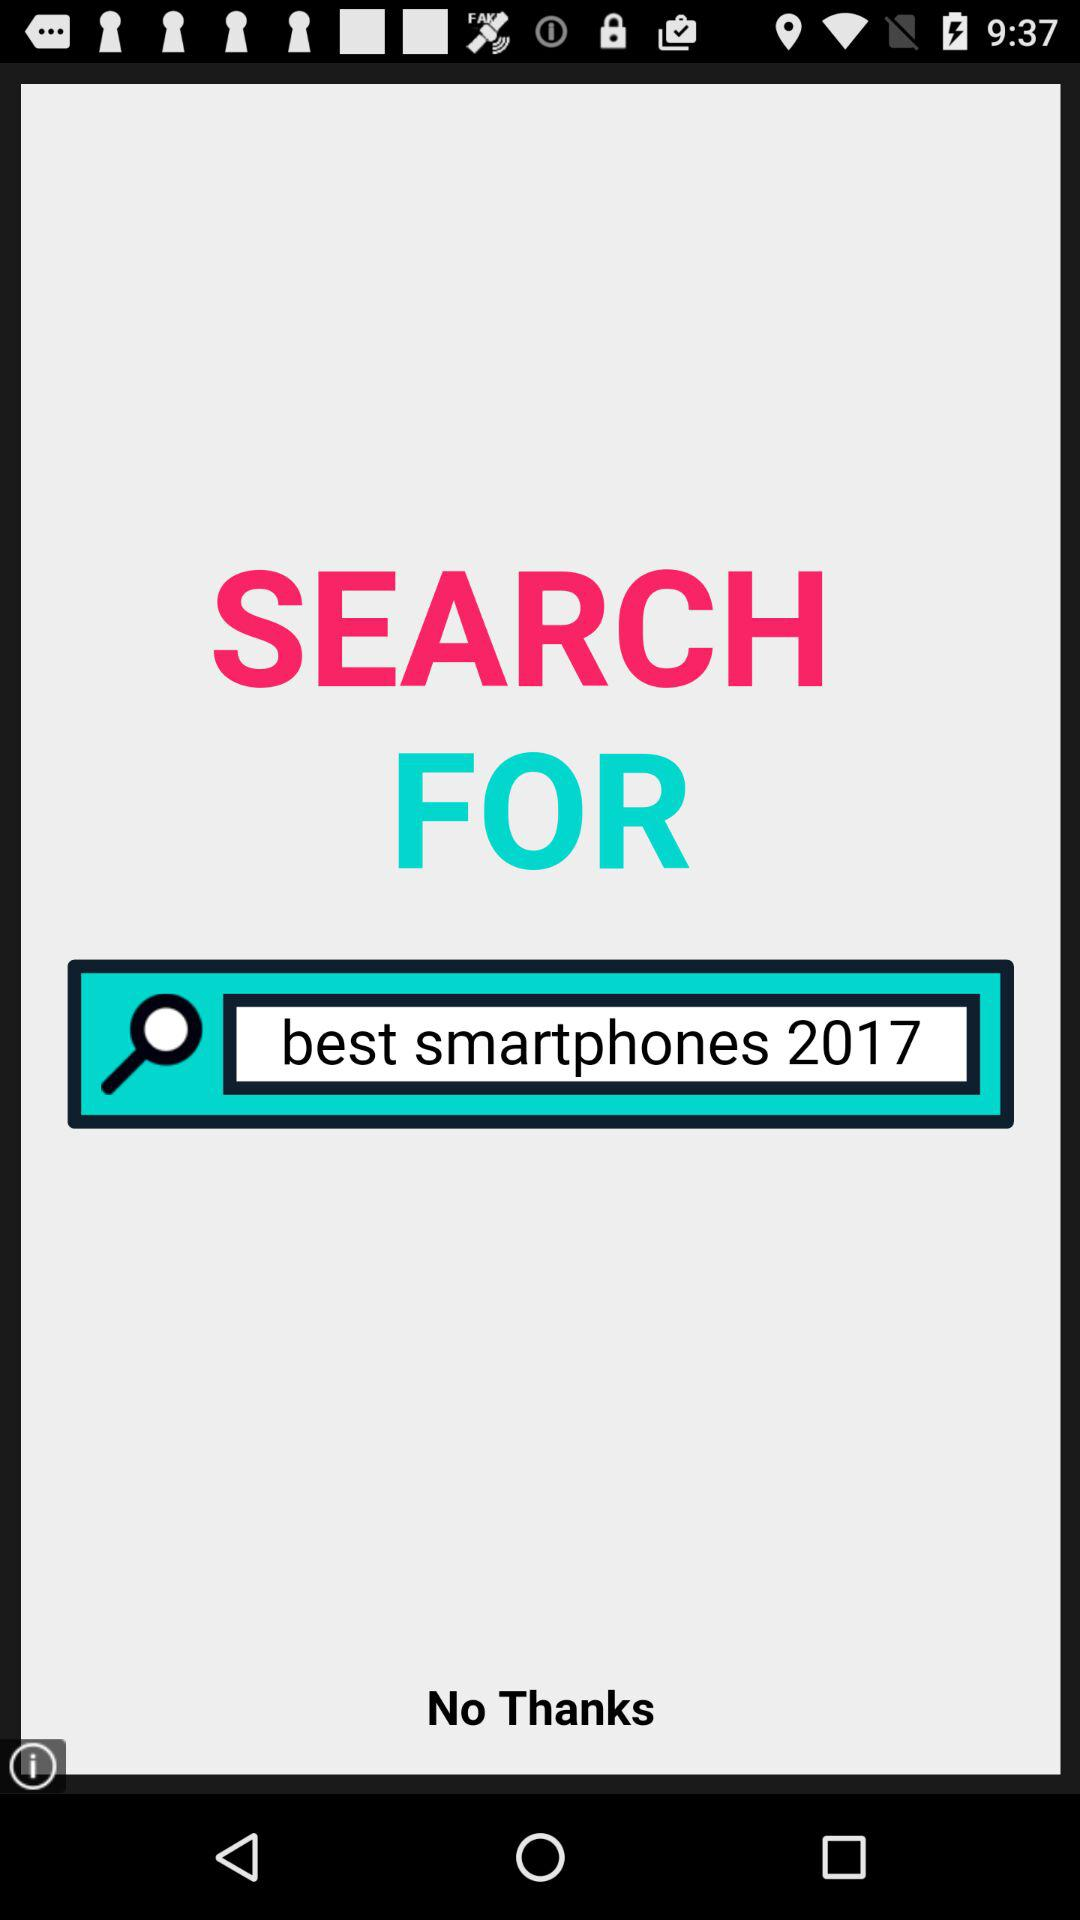What is the selected year for the best smartphones? The selected year for the best smartphones is 2017. 